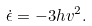Convert formula to latex. <formula><loc_0><loc_0><loc_500><loc_500>\dot { \epsilon } = - 3 h v ^ { 2 } .</formula> 